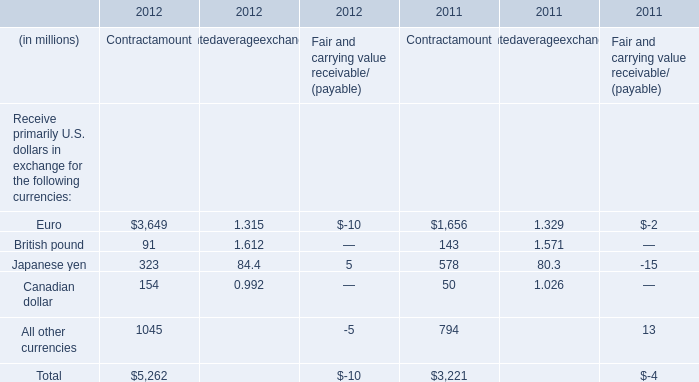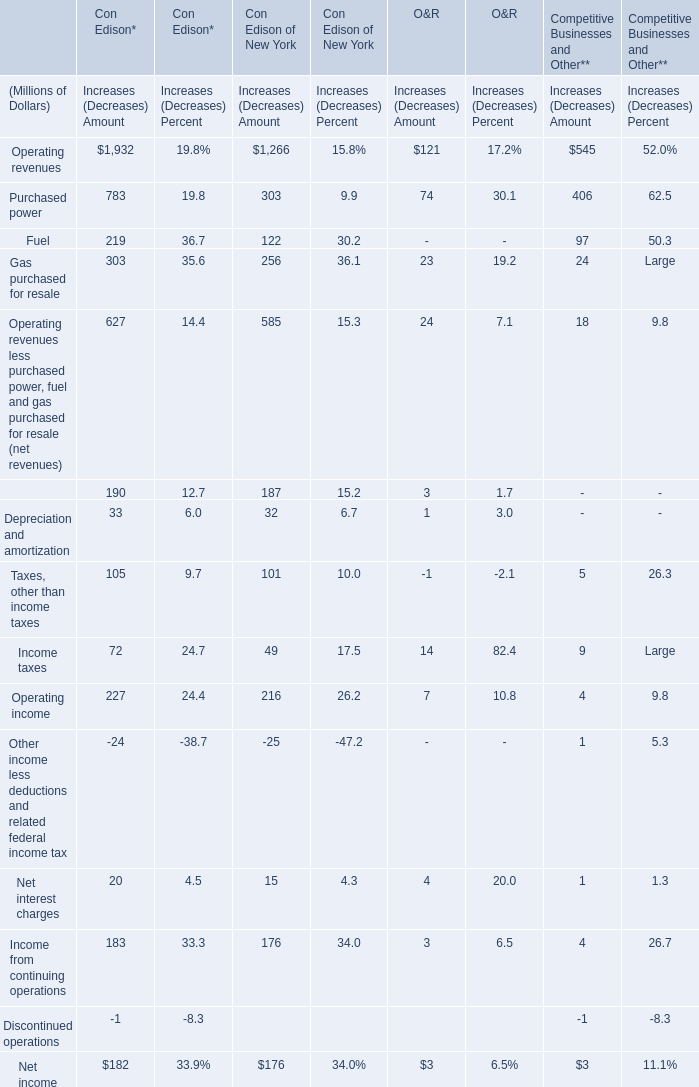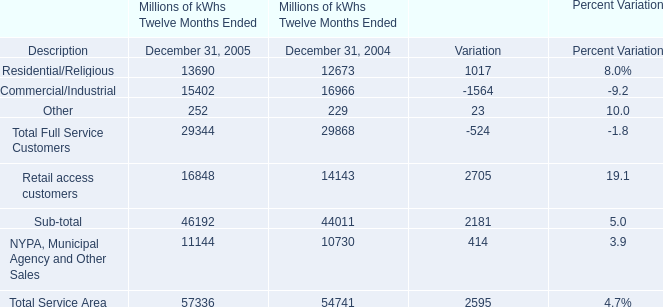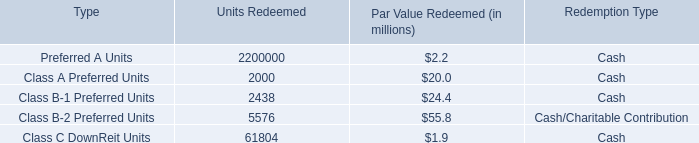What is the average amount of Class C DownReit Units of Units Redeemed 2,200,000 2,000, and Euro of 2011 Contractamount ? 
Computations: ((61804.0 + 1656.0) / 2)
Answer: 31730.0. 